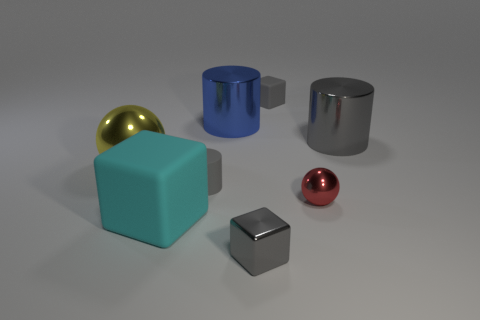Subtract all gray cylinders. How many cylinders are left? 1 Subtract 1 spheres. How many spheres are left? 1 Subtract all tiny gray metallic blocks. Subtract all gray metal cubes. How many objects are left? 6 Add 1 rubber cylinders. How many rubber cylinders are left? 2 Add 3 matte blocks. How many matte blocks exist? 5 Add 1 tiny red objects. How many objects exist? 9 Subtract all large matte blocks. How many blocks are left? 2 Subtract 0 brown balls. How many objects are left? 8 Subtract all cylinders. How many objects are left? 5 Subtract all cyan cylinders. Subtract all cyan balls. How many cylinders are left? 3 